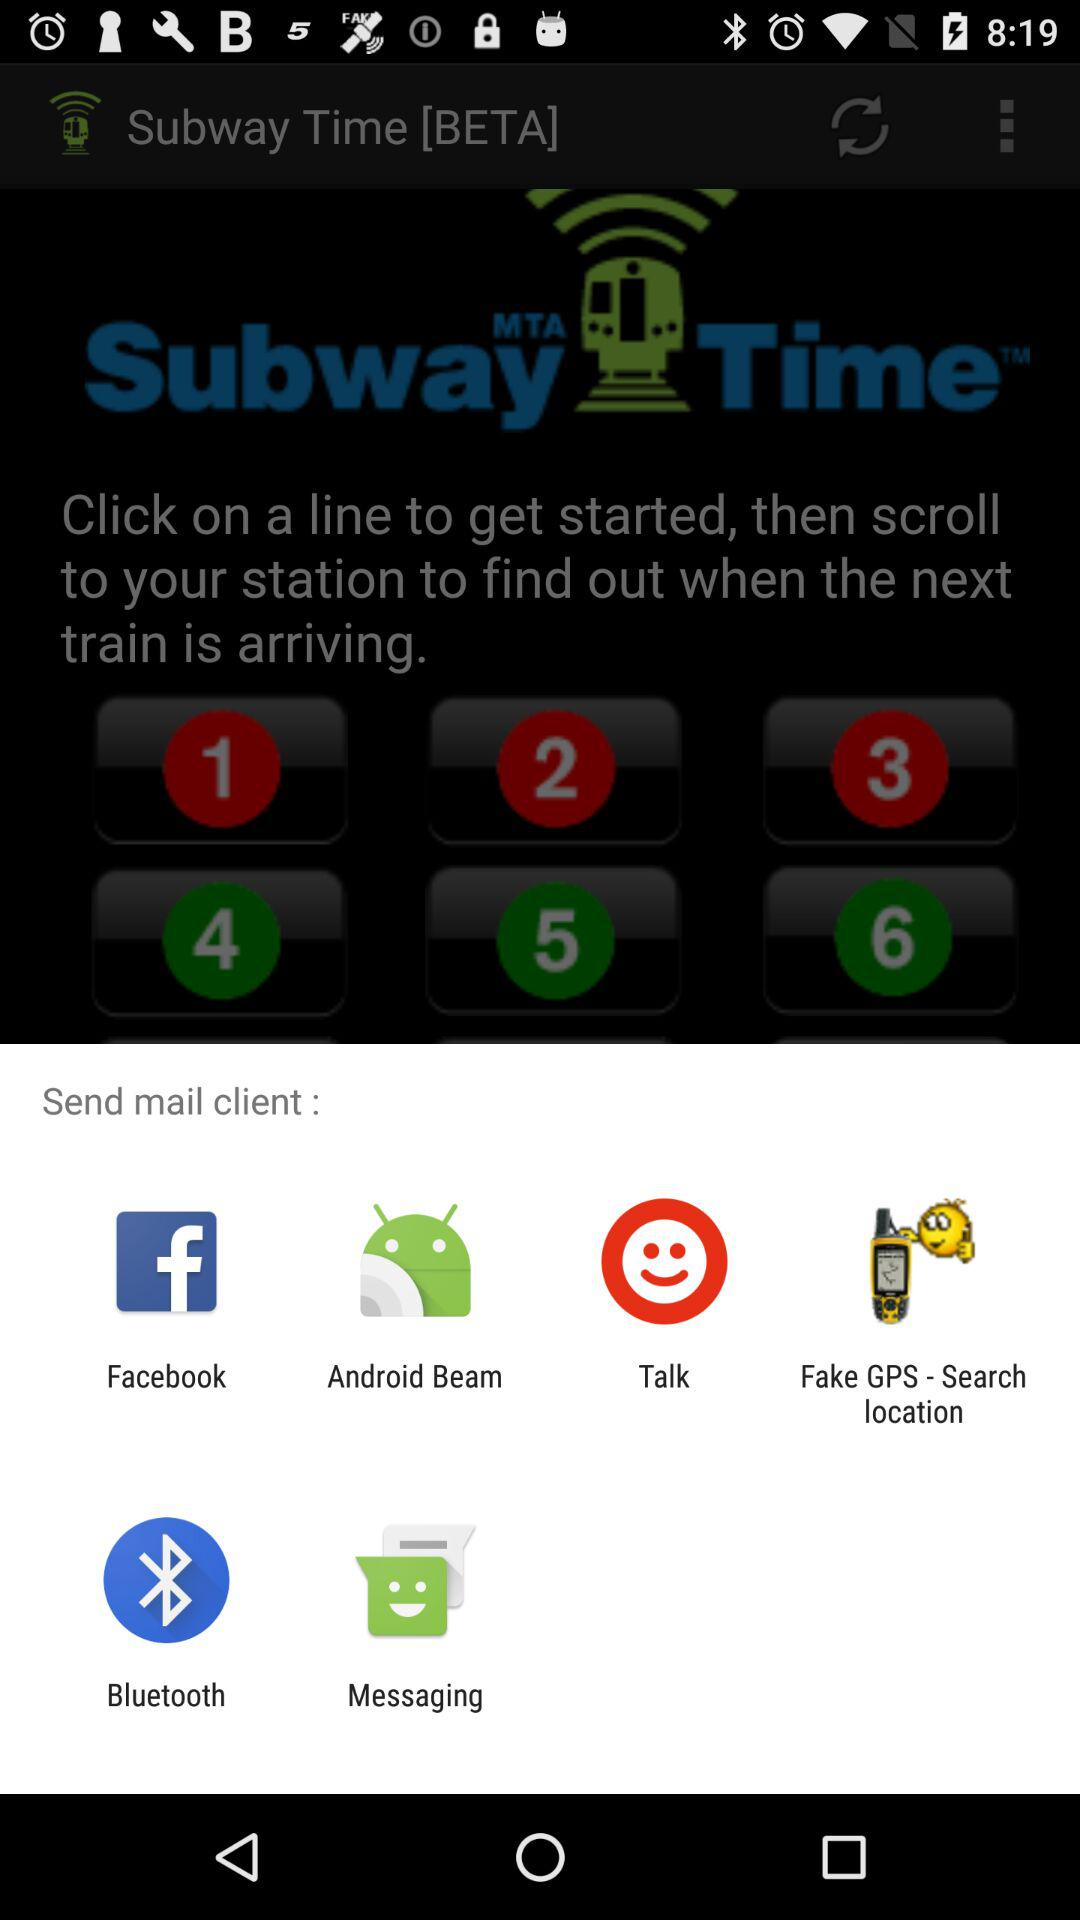How many trains are arriving in less than 15 minutes?
Answer the question using a single word or phrase. 3 